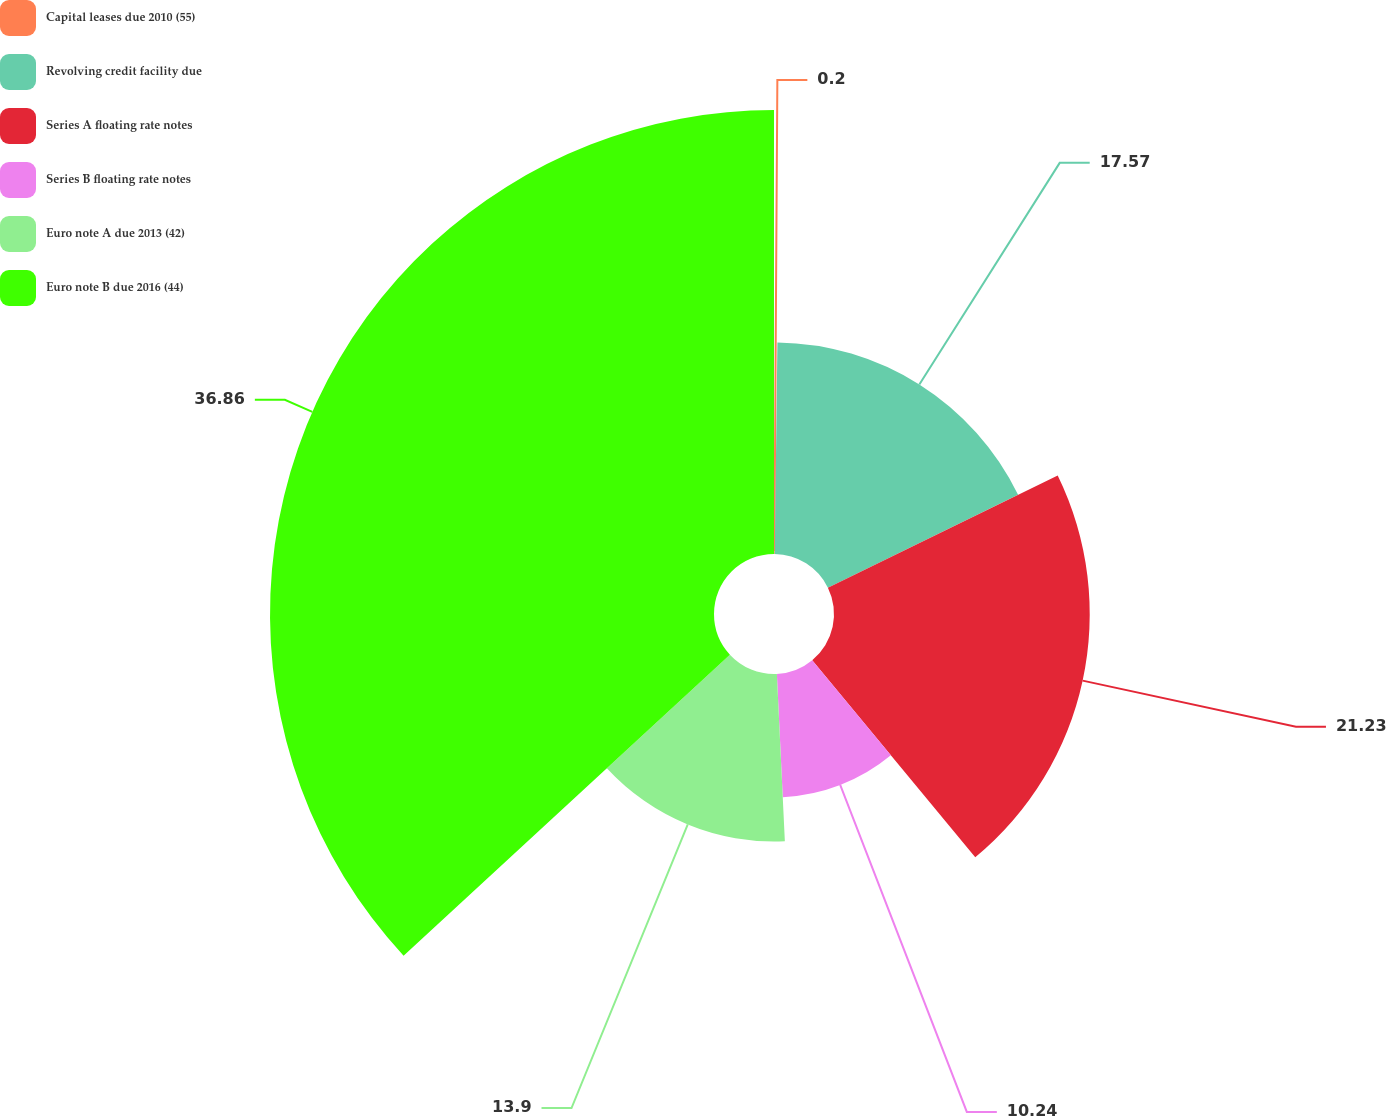Convert chart to OTSL. <chart><loc_0><loc_0><loc_500><loc_500><pie_chart><fcel>Capital leases due 2010 (55)<fcel>Revolving credit facility due<fcel>Series A floating rate notes<fcel>Series B floating rate notes<fcel>Euro note A due 2013 (42)<fcel>Euro note B due 2016 (44)<nl><fcel>0.2%<fcel>17.57%<fcel>21.23%<fcel>10.24%<fcel>13.9%<fcel>36.86%<nl></chart> 